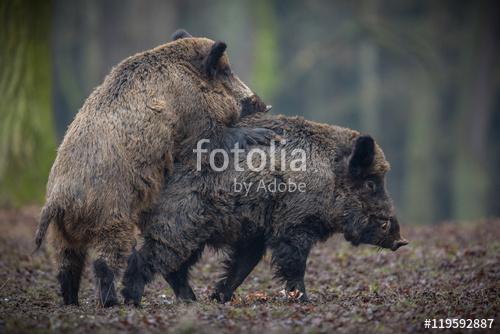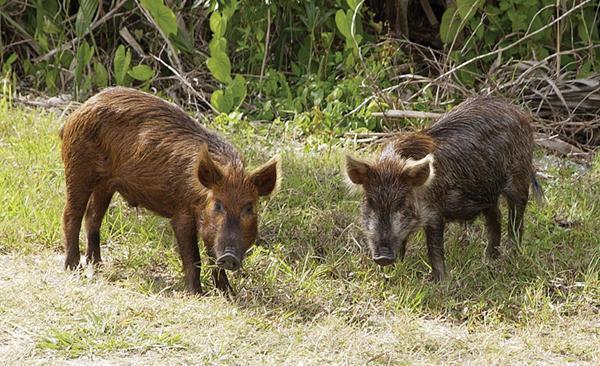The first image is the image on the left, the second image is the image on the right. Examine the images to the left and right. Is the description "There are exactly four pigs." accurate? Answer yes or no. Yes. The first image is the image on the left, the second image is the image on the right. Given the left and right images, does the statement "An image contains at least two baby piglets with distinctive brown and beige striped fur, who are standing on all fours and facing forward." hold true? Answer yes or no. No. 